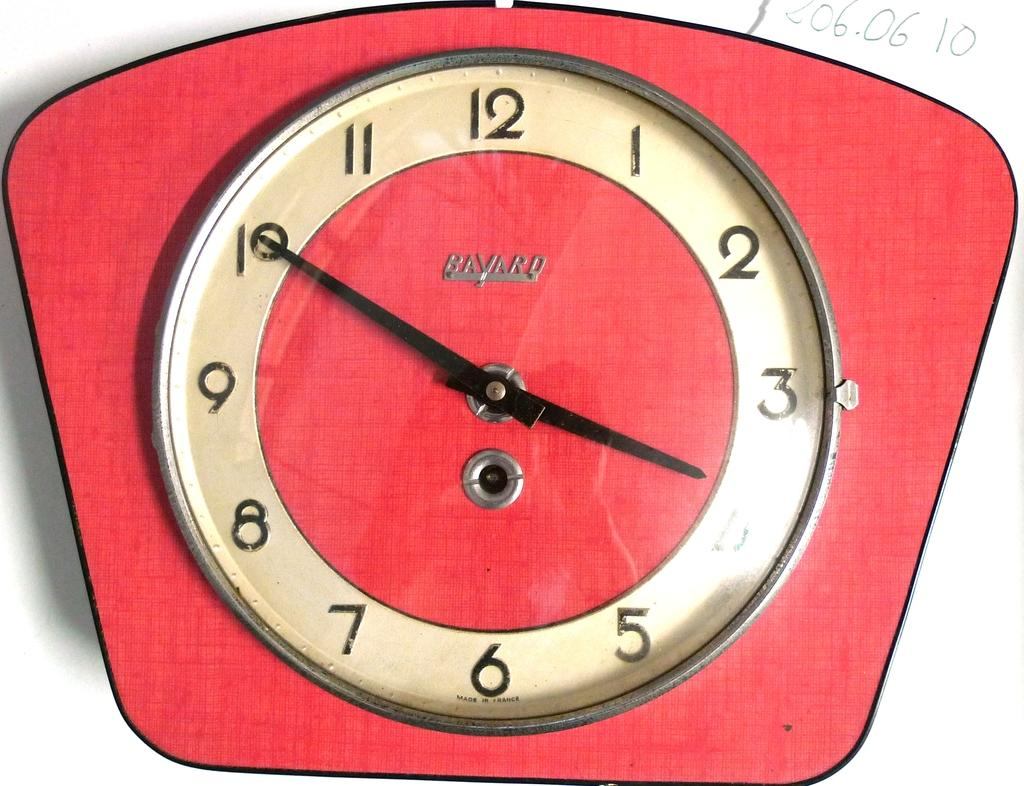<image>
Render a clear and concise summary of the photo. Red Bavaro clock with the hands at 3:50. 